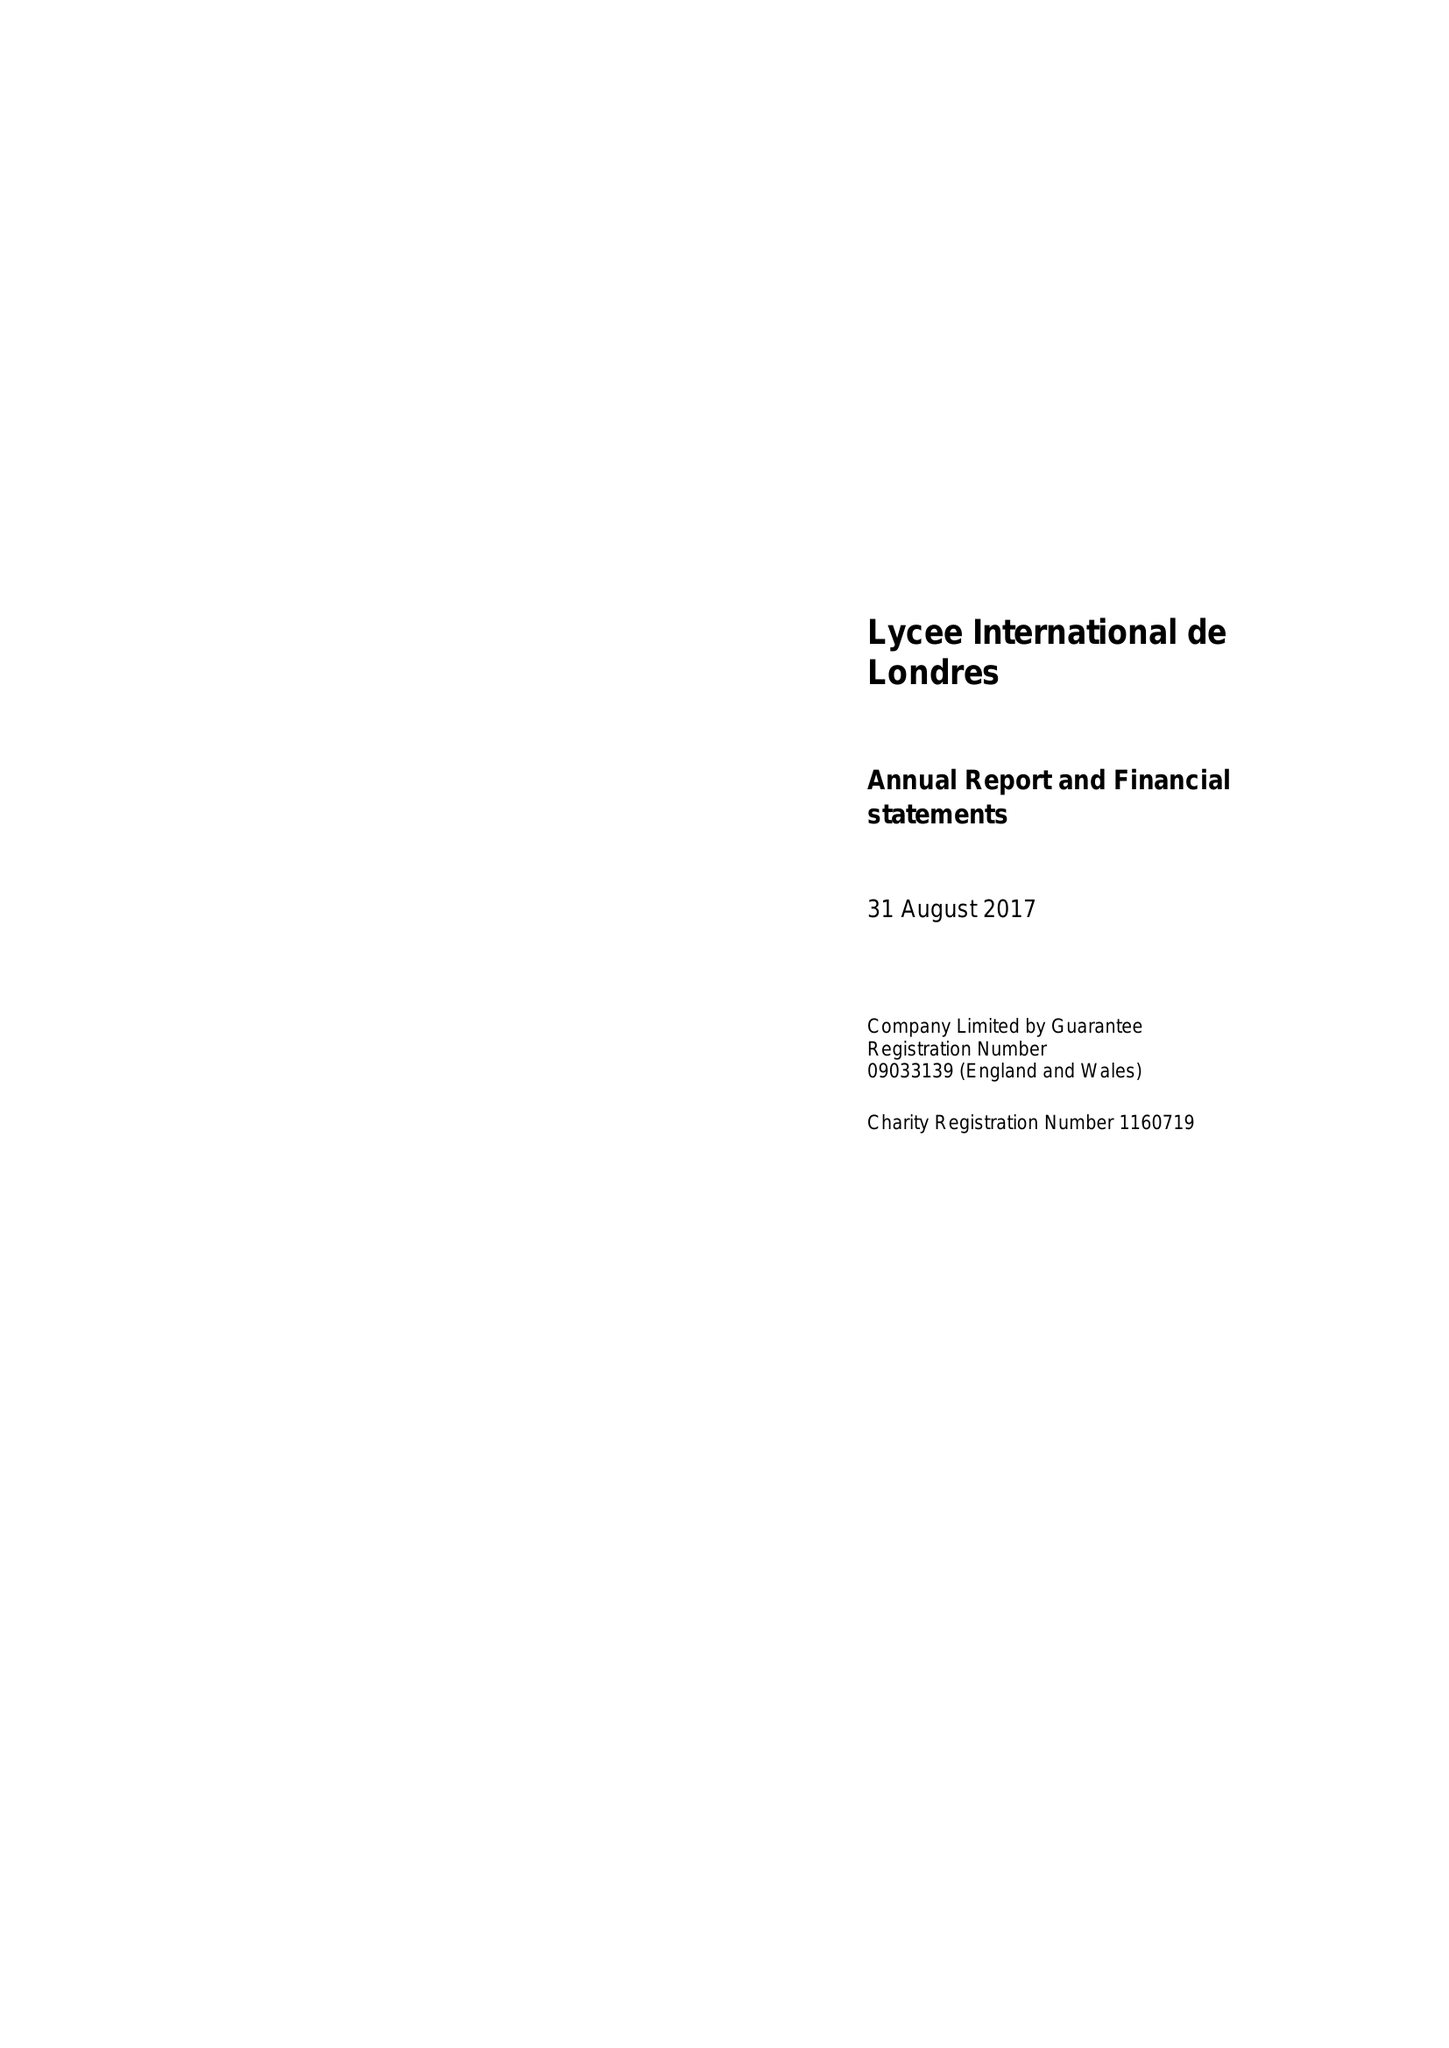What is the value for the address__postcode?
Answer the question using a single word or phrase. HA9 9LY 